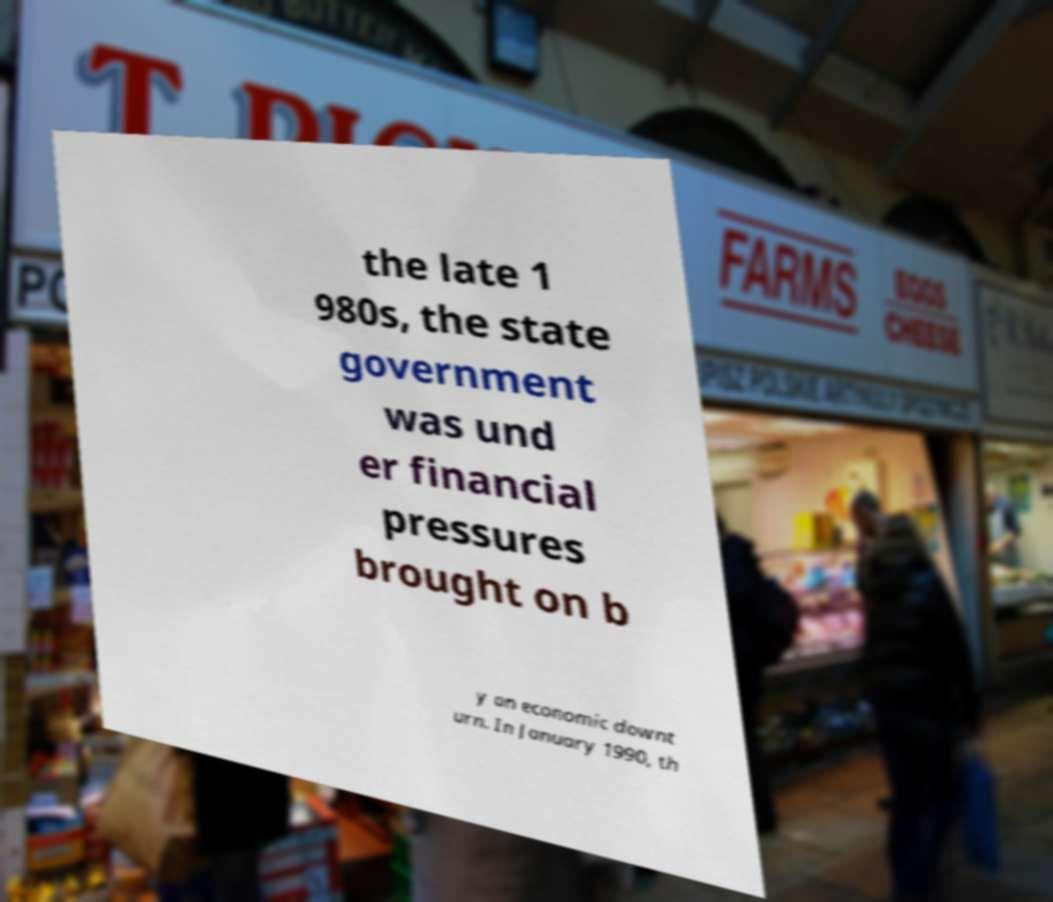Can you accurately transcribe the text from the provided image for me? the late 1 980s, the state government was und er financial pressures brought on b y an economic downt urn. In January 1990, th 